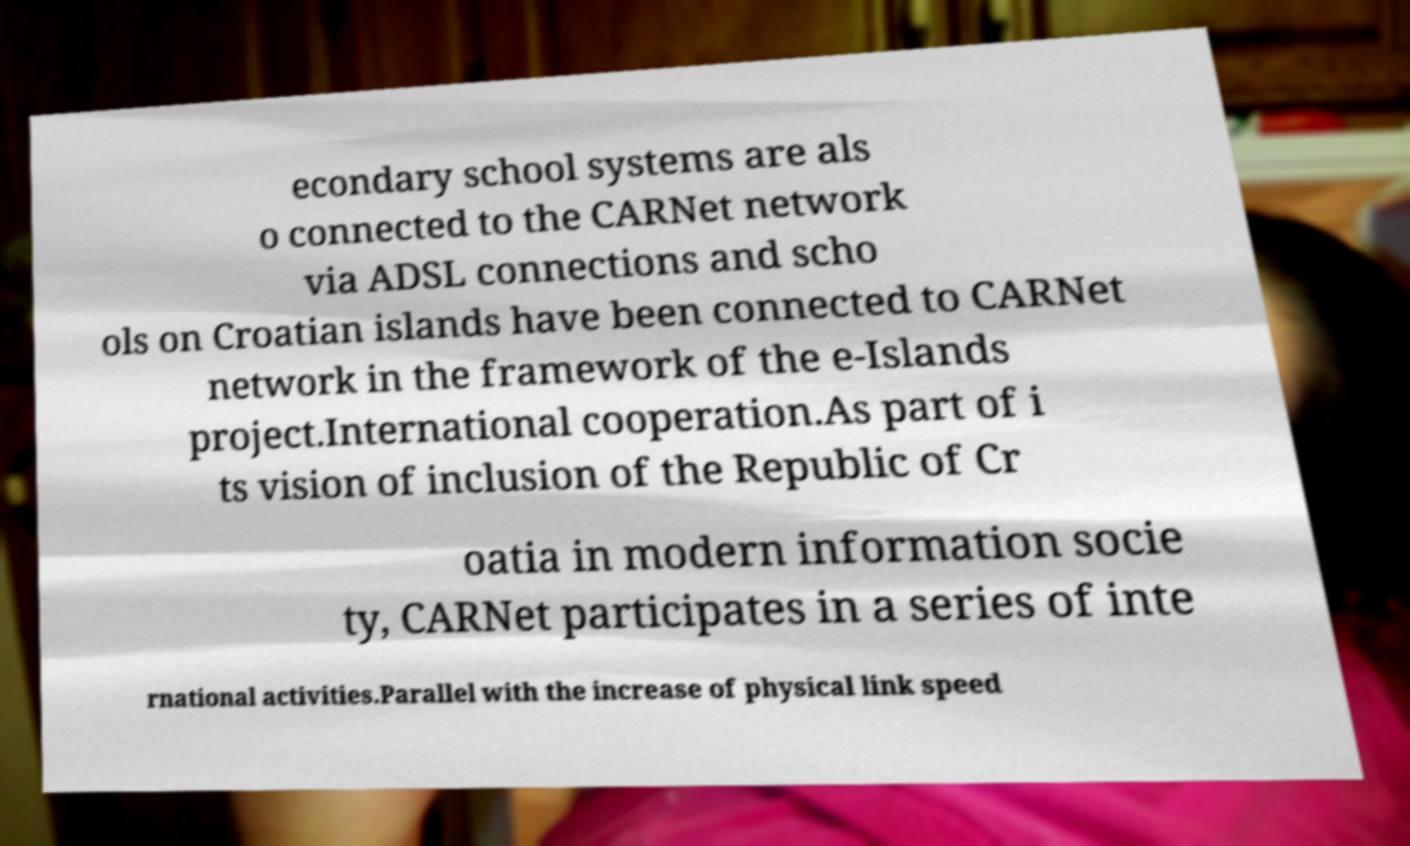I need the written content from this picture converted into text. Can you do that? econdary school systems are als o connected to the CARNet network via ADSL connections and scho ols on Croatian islands have been connected to CARNet network in the framework of the e-Islands project.International cooperation.As part of i ts vision of inclusion of the Republic of Cr oatia in modern information socie ty, CARNet participates in a series of inte rnational activities.Parallel with the increase of physical link speed 